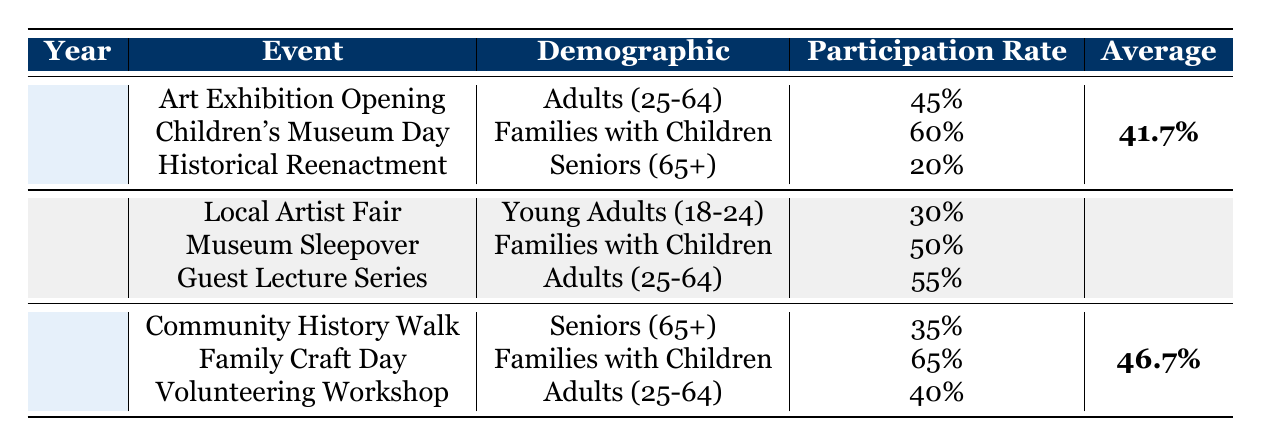What was the participation rate for the "Art Exhibition Opening" in 2021? The table shows that for the event "Art Exhibition Opening" in the year 2021, the Participation Rate listed is 45%.
Answer: 45% Which demographic had the highest participation rate in 2023? Looking at the participation rates for 2023, the "Family Craft Day" for "Families with Children" has the highest participation rate at 65%.
Answer: Families with Children What was the average participation rate for events held in 2022? The three events in 2022 had participation rates of 30%, 50%, and 55%. To calculate the average, we add these rates: 30 + 50 + 55 = 135, and then divide by 3, giving us an average of 45%.
Answer: 45% Did "Seniors (65+)" show an increase in participation from 2021 to 2023 for the event "Community History Walk"? In 2021, "Seniors (65+)" had a participation rate of 20% in "Historical Reenactment". In 2023, the "Community History Walk" saw a rate of 35%. Thus, there was an increase of 15 percentage points.
Answer: Yes What event had the lowest participation rate across all years? From the data, the lowest participation rate is found in 2021 for "Historical Reenactment" under the demographic of "Seniors (65+)", which has a participation rate of 20%.
Answer: Historical Reenactment Which event experienced a decrease in participation from 2021 to 2023, if any? In 2021, the "Art Exhibition Opening" had a participation rate of 45%, and the "Volunteering Workshop" in 2023 had a participation rate of 40%. This indicates a decrease of 5 percentage points.
Answer: Yes What was the combined participation rate for "Families with Children" events across the three years? Summing the participation rates for "Families with Children": 60% (2021, Children's Museum Day) + 50% (2022, Museum Sleepover) + 65% (2023, Family Craft Day) results in 175%. To find the average across three years, we divide by 3: 175/3 = 58.3%.
Answer: 58.3% Which demographic had the lowest overall participation rate in 2021? The table shows two events under different demographics for 2021: "Adults (25-64)" at 45% and "Seniors (65+)" at 20%. Therefore, the lowest is for "Seniors (65+)".
Answer: Seniors (65+) 